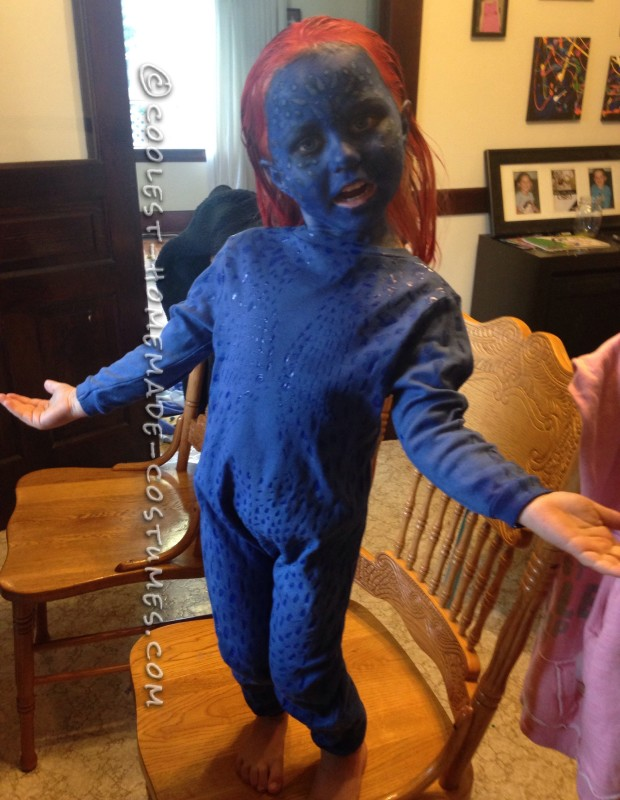Considering the intricate design of the costume, what might be the steps and materials necessary to recreate this character's look for a costume party? To recreate this character's look, begin with acquiring a form-fitting, blue full-body suit. Use darker blue fabric paint or attach darker blue fabric spots to replicate the textured appearance of the costume. For the facial features, use blue face paint and perhaps create raised areas with latex prosthetics that can be painted to match the suit. Making these prosthetics from lightweight, non-toxic, and hypoallergenic materials will ensure comfort. A red wig or temporary hair dye can be used for the hair. Pay attention to details like accurate shading and texturing to enhance the costume's authenticity. Additionally, ensure all materials are safe and comfortable for prolonged wear. 